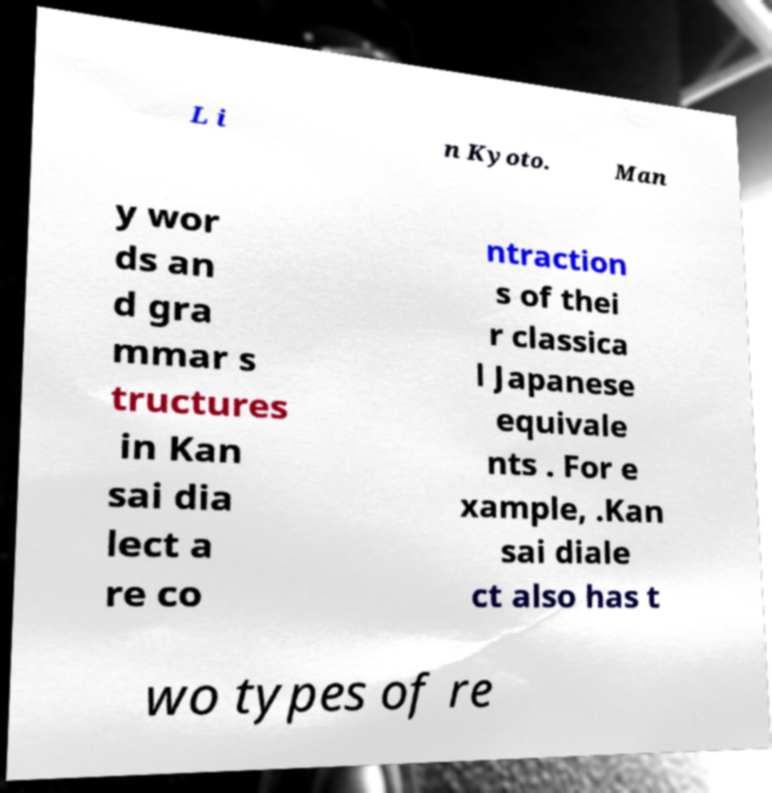Could you extract and type out the text from this image? L i n Kyoto. Man y wor ds an d gra mmar s tructures in Kan sai dia lect a re co ntraction s of thei r classica l Japanese equivale nts . For e xample, .Kan sai diale ct also has t wo types of re 